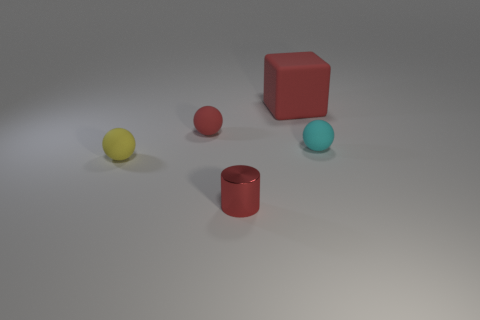Add 1 tiny red spheres. How many objects exist? 6 Subtract all tiny cyan balls. How many balls are left? 2 Subtract all red balls. How many balls are left? 2 Subtract 1 cubes. How many cubes are left? 0 Subtract all spheres. How many objects are left? 2 Subtract all rubber things. Subtract all tiny purple matte cylinders. How many objects are left? 1 Add 5 tiny shiny objects. How many tiny shiny objects are left? 6 Add 4 red rubber blocks. How many red rubber blocks exist? 5 Subtract 0 blue spheres. How many objects are left? 5 Subtract all purple cylinders. Subtract all purple blocks. How many cylinders are left? 1 